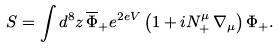Convert formula to latex. <formula><loc_0><loc_0><loc_500><loc_500>S = \int d ^ { 8 } z \, \overline { \Phi } _ { + } e ^ { 2 e V } \left ( 1 + i N _ { + } ^ { \mu } \, \nabla _ { \mu } \right ) \Phi _ { + } .</formula> 